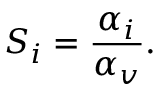<formula> <loc_0><loc_0><loc_500><loc_500>S _ { i } = \frac { \alpha _ { i } } { \alpha _ { v } } .</formula> 